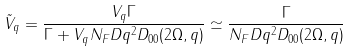<formula> <loc_0><loc_0><loc_500><loc_500>\tilde { V } _ { q } = \frac { V _ { q } \Gamma } { \Gamma + V _ { q } N _ { F } D q ^ { 2 } D _ { 0 0 } ( 2 \Omega , q ) } \simeq \frac { \Gamma } { N _ { F } D q ^ { 2 } D _ { 0 0 } ( 2 \Omega , q ) }</formula> 